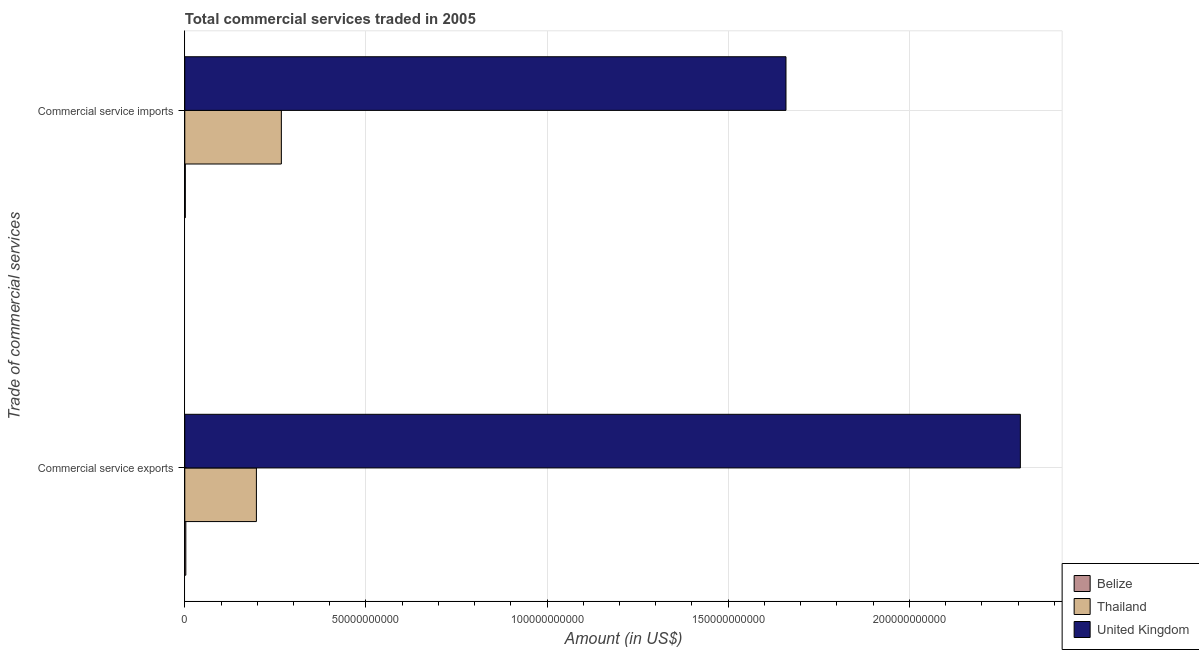How many different coloured bars are there?
Your answer should be compact. 3. Are the number of bars per tick equal to the number of legend labels?
Provide a succinct answer. Yes. How many bars are there on the 1st tick from the top?
Your answer should be compact. 3. What is the label of the 2nd group of bars from the top?
Give a very brief answer. Commercial service exports. What is the amount of commercial service exports in Thailand?
Provide a succinct answer. 1.98e+1. Across all countries, what is the maximum amount of commercial service exports?
Offer a very short reply. 2.31e+11. Across all countries, what is the minimum amount of commercial service exports?
Ensure brevity in your answer.  2.89e+08. In which country was the amount of commercial service exports maximum?
Keep it short and to the point. United Kingdom. In which country was the amount of commercial service exports minimum?
Provide a short and direct response. Belize. What is the total amount of commercial service imports in the graph?
Ensure brevity in your answer.  1.93e+11. What is the difference between the amount of commercial service exports in Thailand and that in Belize?
Offer a very short reply. 1.95e+1. What is the difference between the amount of commercial service imports in United Kingdom and the amount of commercial service exports in Thailand?
Your answer should be compact. 1.46e+11. What is the average amount of commercial service imports per country?
Give a very brief answer. 6.42e+1. What is the difference between the amount of commercial service exports and amount of commercial service imports in Thailand?
Provide a succinct answer. -6.89e+09. In how many countries, is the amount of commercial service exports greater than 180000000000 US$?
Provide a short and direct response. 1. What is the ratio of the amount of commercial service imports in United Kingdom to that in Thailand?
Your answer should be very brief. 6.23. In how many countries, is the amount of commercial service exports greater than the average amount of commercial service exports taken over all countries?
Your answer should be very brief. 1. What does the 2nd bar from the bottom in Commercial service imports represents?
Your answer should be compact. Thailand. Are all the bars in the graph horizontal?
Keep it short and to the point. Yes. How many countries are there in the graph?
Your answer should be compact. 3. What is the difference between two consecutive major ticks on the X-axis?
Make the answer very short. 5.00e+1. Are the values on the major ticks of X-axis written in scientific E-notation?
Provide a succinct answer. No. Does the graph contain any zero values?
Ensure brevity in your answer.  No. Does the graph contain grids?
Provide a short and direct response. Yes. How many legend labels are there?
Ensure brevity in your answer.  3. What is the title of the graph?
Offer a terse response. Total commercial services traded in 2005. What is the label or title of the X-axis?
Ensure brevity in your answer.  Amount (in US$). What is the label or title of the Y-axis?
Make the answer very short. Trade of commercial services. What is the Amount (in US$) of Belize in Commercial service exports?
Offer a terse response. 2.89e+08. What is the Amount (in US$) of Thailand in Commercial service exports?
Offer a very short reply. 1.98e+1. What is the Amount (in US$) in United Kingdom in Commercial service exports?
Your answer should be compact. 2.31e+11. What is the Amount (in US$) in Belize in Commercial service imports?
Make the answer very short. 1.47e+08. What is the Amount (in US$) of Thailand in Commercial service imports?
Your answer should be very brief. 2.67e+1. What is the Amount (in US$) in United Kingdom in Commercial service imports?
Give a very brief answer. 1.66e+11. Across all Trade of commercial services, what is the maximum Amount (in US$) in Belize?
Make the answer very short. 2.89e+08. Across all Trade of commercial services, what is the maximum Amount (in US$) in Thailand?
Provide a short and direct response. 2.67e+1. Across all Trade of commercial services, what is the maximum Amount (in US$) in United Kingdom?
Your answer should be compact. 2.31e+11. Across all Trade of commercial services, what is the minimum Amount (in US$) of Belize?
Offer a terse response. 1.47e+08. Across all Trade of commercial services, what is the minimum Amount (in US$) in Thailand?
Offer a terse response. 1.98e+1. Across all Trade of commercial services, what is the minimum Amount (in US$) in United Kingdom?
Make the answer very short. 1.66e+11. What is the total Amount (in US$) of Belize in the graph?
Offer a terse response. 4.36e+08. What is the total Amount (in US$) of Thailand in the graph?
Make the answer very short. 4.64e+1. What is the total Amount (in US$) of United Kingdom in the graph?
Your answer should be very brief. 3.97e+11. What is the difference between the Amount (in US$) in Belize in Commercial service exports and that in Commercial service imports?
Ensure brevity in your answer.  1.42e+08. What is the difference between the Amount (in US$) in Thailand in Commercial service exports and that in Commercial service imports?
Ensure brevity in your answer.  -6.89e+09. What is the difference between the Amount (in US$) in United Kingdom in Commercial service exports and that in Commercial service imports?
Offer a very short reply. 6.47e+1. What is the difference between the Amount (in US$) in Belize in Commercial service exports and the Amount (in US$) in Thailand in Commercial service imports?
Your answer should be compact. -2.64e+1. What is the difference between the Amount (in US$) in Belize in Commercial service exports and the Amount (in US$) in United Kingdom in Commercial service imports?
Provide a succinct answer. -1.66e+11. What is the difference between the Amount (in US$) of Thailand in Commercial service exports and the Amount (in US$) of United Kingdom in Commercial service imports?
Keep it short and to the point. -1.46e+11. What is the average Amount (in US$) in Belize per Trade of commercial services?
Ensure brevity in your answer.  2.18e+08. What is the average Amount (in US$) in Thailand per Trade of commercial services?
Offer a very short reply. 2.32e+1. What is the average Amount (in US$) in United Kingdom per Trade of commercial services?
Offer a terse response. 1.98e+11. What is the difference between the Amount (in US$) of Belize and Amount (in US$) of Thailand in Commercial service exports?
Provide a succinct answer. -1.95e+1. What is the difference between the Amount (in US$) in Belize and Amount (in US$) in United Kingdom in Commercial service exports?
Provide a short and direct response. -2.30e+11. What is the difference between the Amount (in US$) in Thailand and Amount (in US$) in United Kingdom in Commercial service exports?
Your answer should be compact. -2.11e+11. What is the difference between the Amount (in US$) in Belize and Amount (in US$) in Thailand in Commercial service imports?
Your answer should be compact. -2.65e+1. What is the difference between the Amount (in US$) of Belize and Amount (in US$) of United Kingdom in Commercial service imports?
Give a very brief answer. -1.66e+11. What is the difference between the Amount (in US$) in Thailand and Amount (in US$) in United Kingdom in Commercial service imports?
Keep it short and to the point. -1.39e+11. What is the ratio of the Amount (in US$) in Belize in Commercial service exports to that in Commercial service imports?
Your answer should be compact. 1.96. What is the ratio of the Amount (in US$) of Thailand in Commercial service exports to that in Commercial service imports?
Make the answer very short. 0.74. What is the ratio of the Amount (in US$) in United Kingdom in Commercial service exports to that in Commercial service imports?
Provide a short and direct response. 1.39. What is the difference between the highest and the second highest Amount (in US$) in Belize?
Your answer should be very brief. 1.42e+08. What is the difference between the highest and the second highest Amount (in US$) in Thailand?
Make the answer very short. 6.89e+09. What is the difference between the highest and the second highest Amount (in US$) of United Kingdom?
Provide a short and direct response. 6.47e+1. What is the difference between the highest and the lowest Amount (in US$) of Belize?
Offer a terse response. 1.42e+08. What is the difference between the highest and the lowest Amount (in US$) in Thailand?
Provide a succinct answer. 6.89e+09. What is the difference between the highest and the lowest Amount (in US$) of United Kingdom?
Your response must be concise. 6.47e+1. 